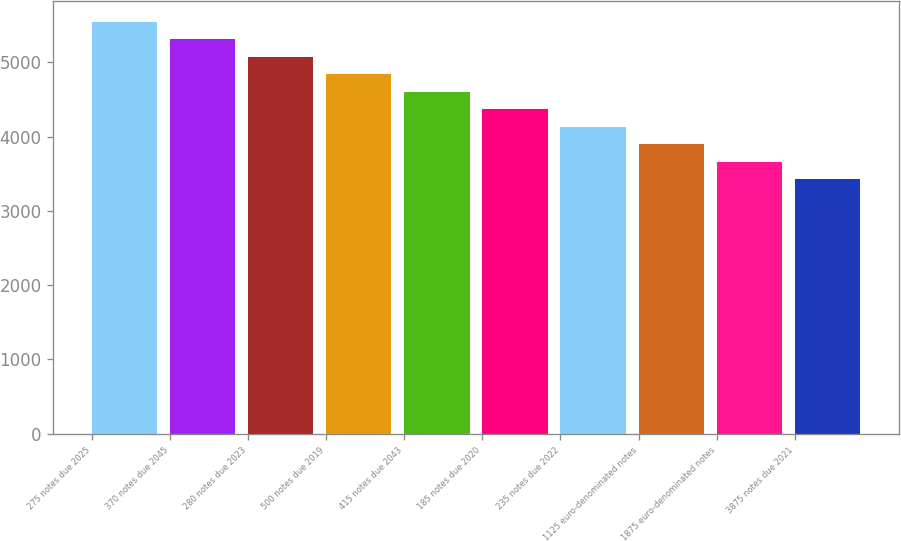<chart> <loc_0><loc_0><loc_500><loc_500><bar_chart><fcel>275 notes due 2025<fcel>370 notes due 2045<fcel>280 notes due 2023<fcel>500 notes due 2019<fcel>415 notes due 2043<fcel>185 notes due 2020<fcel>235 notes due 2022<fcel>1125 euro-denominated notes<fcel>1875 euro-denominated notes<fcel>3875 notes due 2021<nl><fcel>5546.9<fcel>5311.6<fcel>5076.3<fcel>4841<fcel>4605.7<fcel>4370.4<fcel>4135.1<fcel>3899.8<fcel>3664.5<fcel>3429.2<nl></chart> 